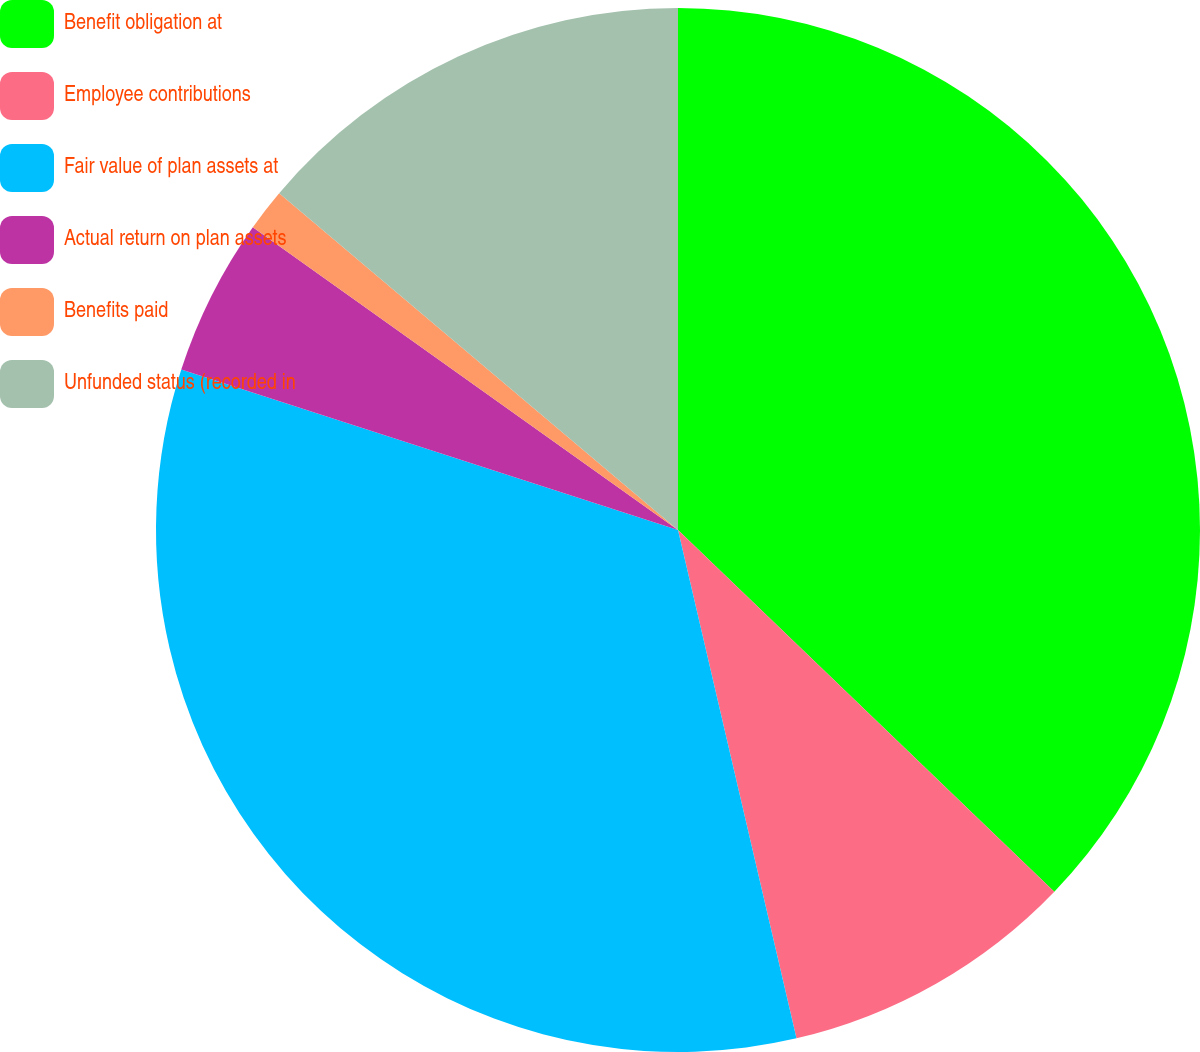Convert chart. <chart><loc_0><loc_0><loc_500><loc_500><pie_chart><fcel>Benefit obligation at<fcel>Employee contributions<fcel>Fair value of plan assets at<fcel>Actual return on plan assets<fcel>Benefits paid<fcel>Unfunded status (recorded in<nl><fcel>37.19%<fcel>9.17%<fcel>33.62%<fcel>4.88%<fcel>1.31%<fcel>13.84%<nl></chart> 